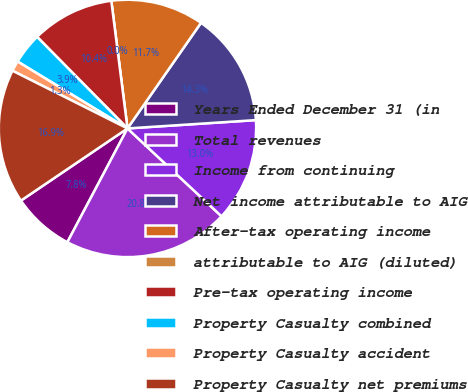Convert chart to OTSL. <chart><loc_0><loc_0><loc_500><loc_500><pie_chart><fcel>Years Ended December 31 (in<fcel>Total revenues<fcel>Income from continuing<fcel>Net income attributable to AIG<fcel>After-tax operating income<fcel>attributable to AIG (diluted)<fcel>Pre-tax operating income<fcel>Property Casualty combined<fcel>Property Casualty accident<fcel>Property Casualty net premiums<nl><fcel>7.79%<fcel>20.78%<fcel>12.99%<fcel>14.29%<fcel>11.69%<fcel>0.0%<fcel>10.39%<fcel>3.9%<fcel>1.3%<fcel>16.88%<nl></chart> 